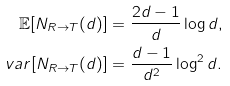<formula> <loc_0><loc_0><loc_500><loc_500>\mathbb { E } [ N _ { R \to T } ( d ) ] & = \frac { 2 d - 1 } { d } \log d , \\ v a r [ N _ { R \to T } ( d ) ] & = \frac { d - 1 } { d ^ { 2 } } \log ^ { 2 } d .</formula> 